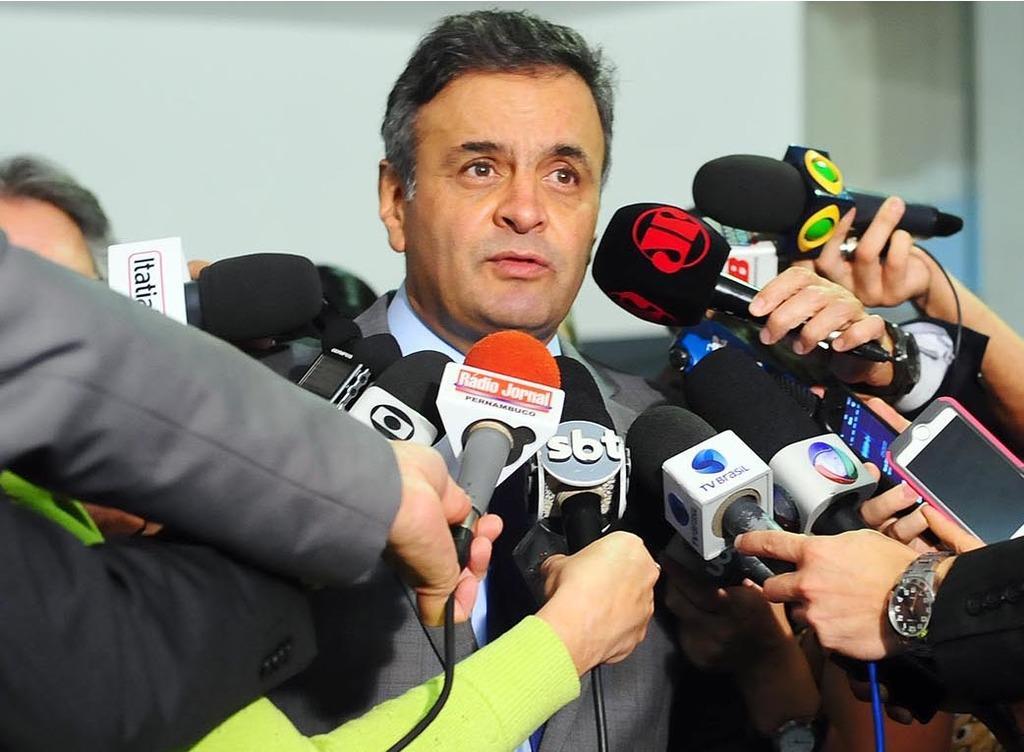In one or two sentences, can you explain what this image depicts? In the Image I can see some mics around the person and also we can see a phone. 